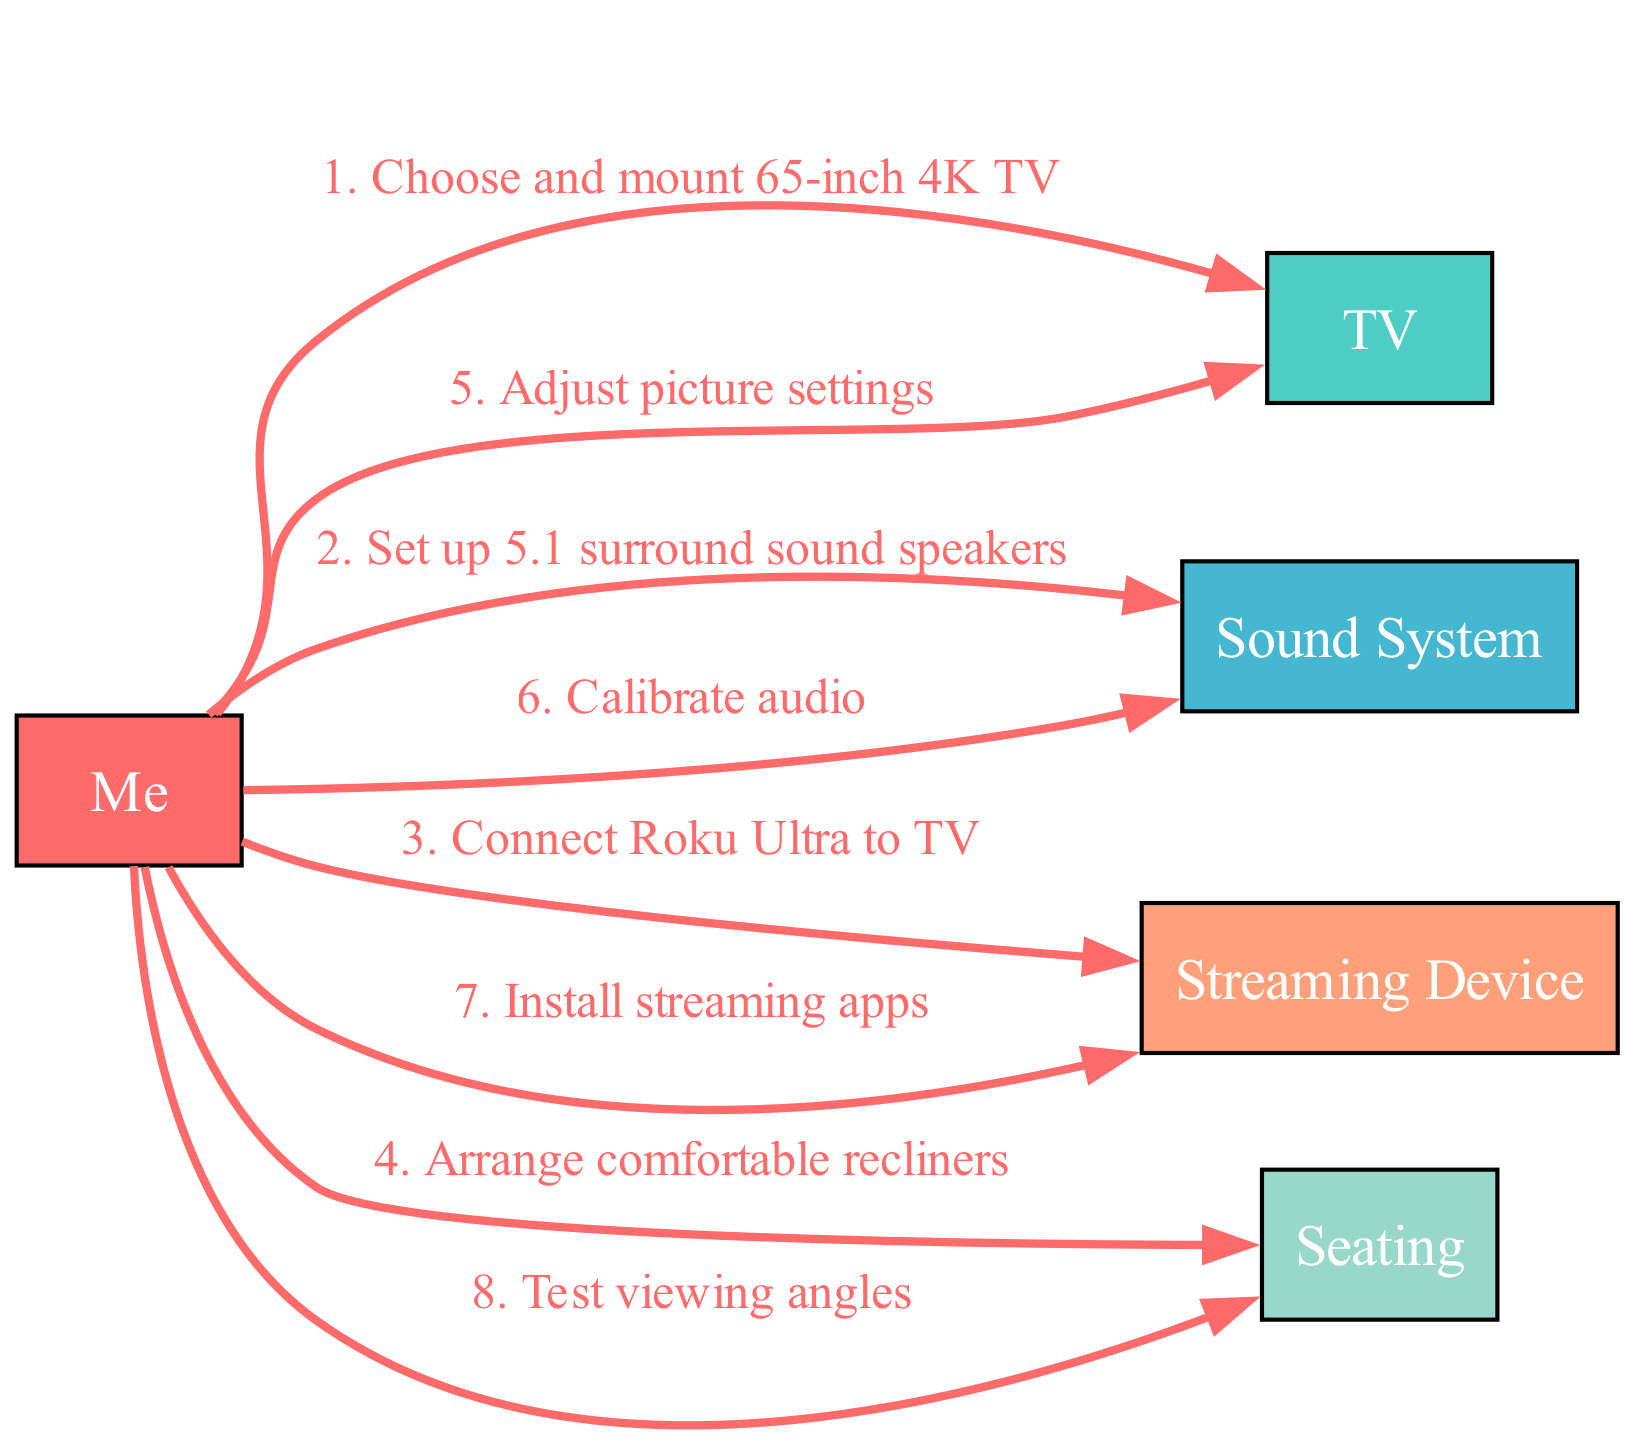What is the first action taken in setting up the home theater? The first action taken is "Choose and mount 65-inch 4K TV." This is indicated by the first item in the sequence that connects "Me" to "TV."
Answer: Choose and mount 65-inch 4K TV How many actors are involved in the sequence? The sequence includes five distinct actors: "Me," "TV," "Sound System," "Streaming Device," and "Seating." By counting these unique names, we find a total of five actors.
Answer: 5 What action follows after calibrating audio? The action that follows "Calibrate audio" is "Install streaming apps." This can be determined by looking for the sequence connection that comes after the audio calibration step.
Answer: Install streaming apps Which actor is involved in adjusting picture settings? The actor responsible for "Adjust picture settings" is "Me." This is derived from tracing the action that connects "Me" to "TV" in the sequence diagram.
Answer: Me What is the last action in the home theater setup sequence? The last action listed is "Test viewing angles," which is the final connection made in the sequence. This can be recognized as the endpoint of the actions taken by "Me."
Answer: Test viewing angles How many actions involve the "Sound System"? The "Sound System" is involved in two distinct actions: "Set up 5.1 surround sound speakers" and "Calibrate audio." By counting these interactions, we find that there are two actions associated with the "Sound System."
Answer: 2 What is the purpose of arranging comfortable recliners? The purpose of arranging comfortable recliners is to enhance the viewing experience, as outlined by the action "Arrange comfortable recliners" conducted by "Me." This contributes to creating an optimal setup for watching movies.
Answer: Enhance viewing experience Which actions are executed by "Me"? "Me" executes the following actions: "Choose and mount 65-inch 4K TV," "Set up 5.1 surround sound speakers," "Connect Roku Ultra to TV," "Arrange comfortable recliners," "Adjust picture settings," "Calibrate audio," "Install streaming apps," and "Test viewing angles." This highlights all the contributions made by "Me" during the setup process.
Answer: All actions in the sequence 